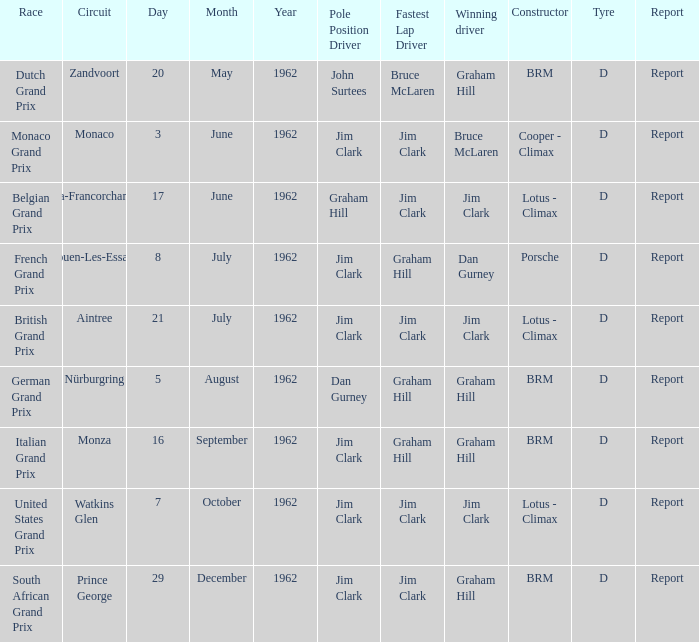What is the date of the circuit of nürburgring, which had Graham Hill as the winning driver? 5 August. 